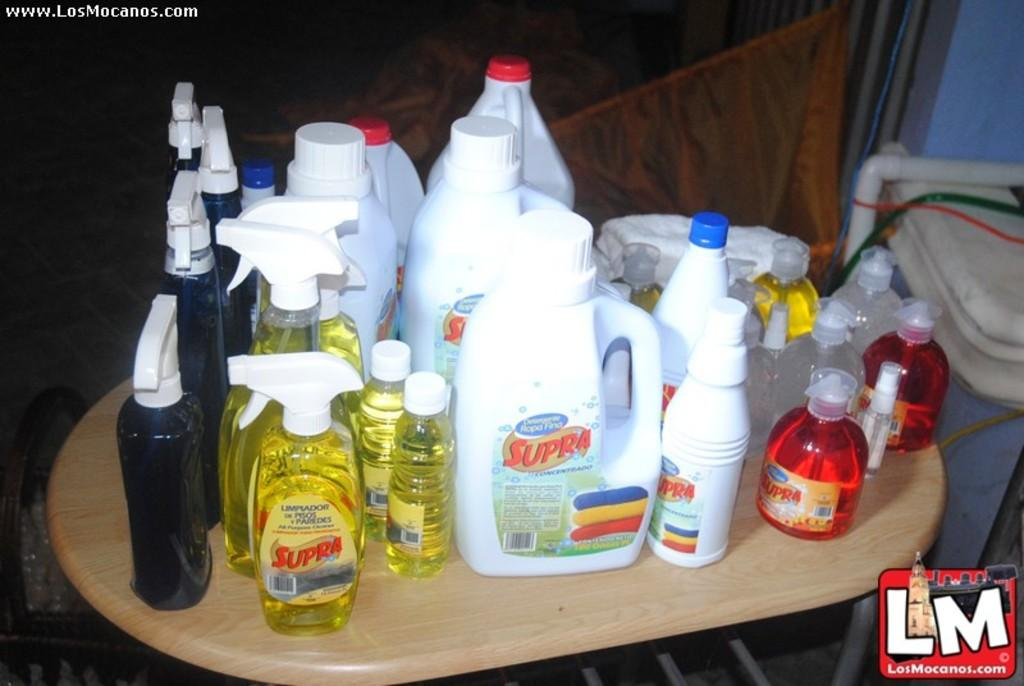<image>
Relay a brief, clear account of the picture shown. A table full of cleaners that have the word Supra written on it. 